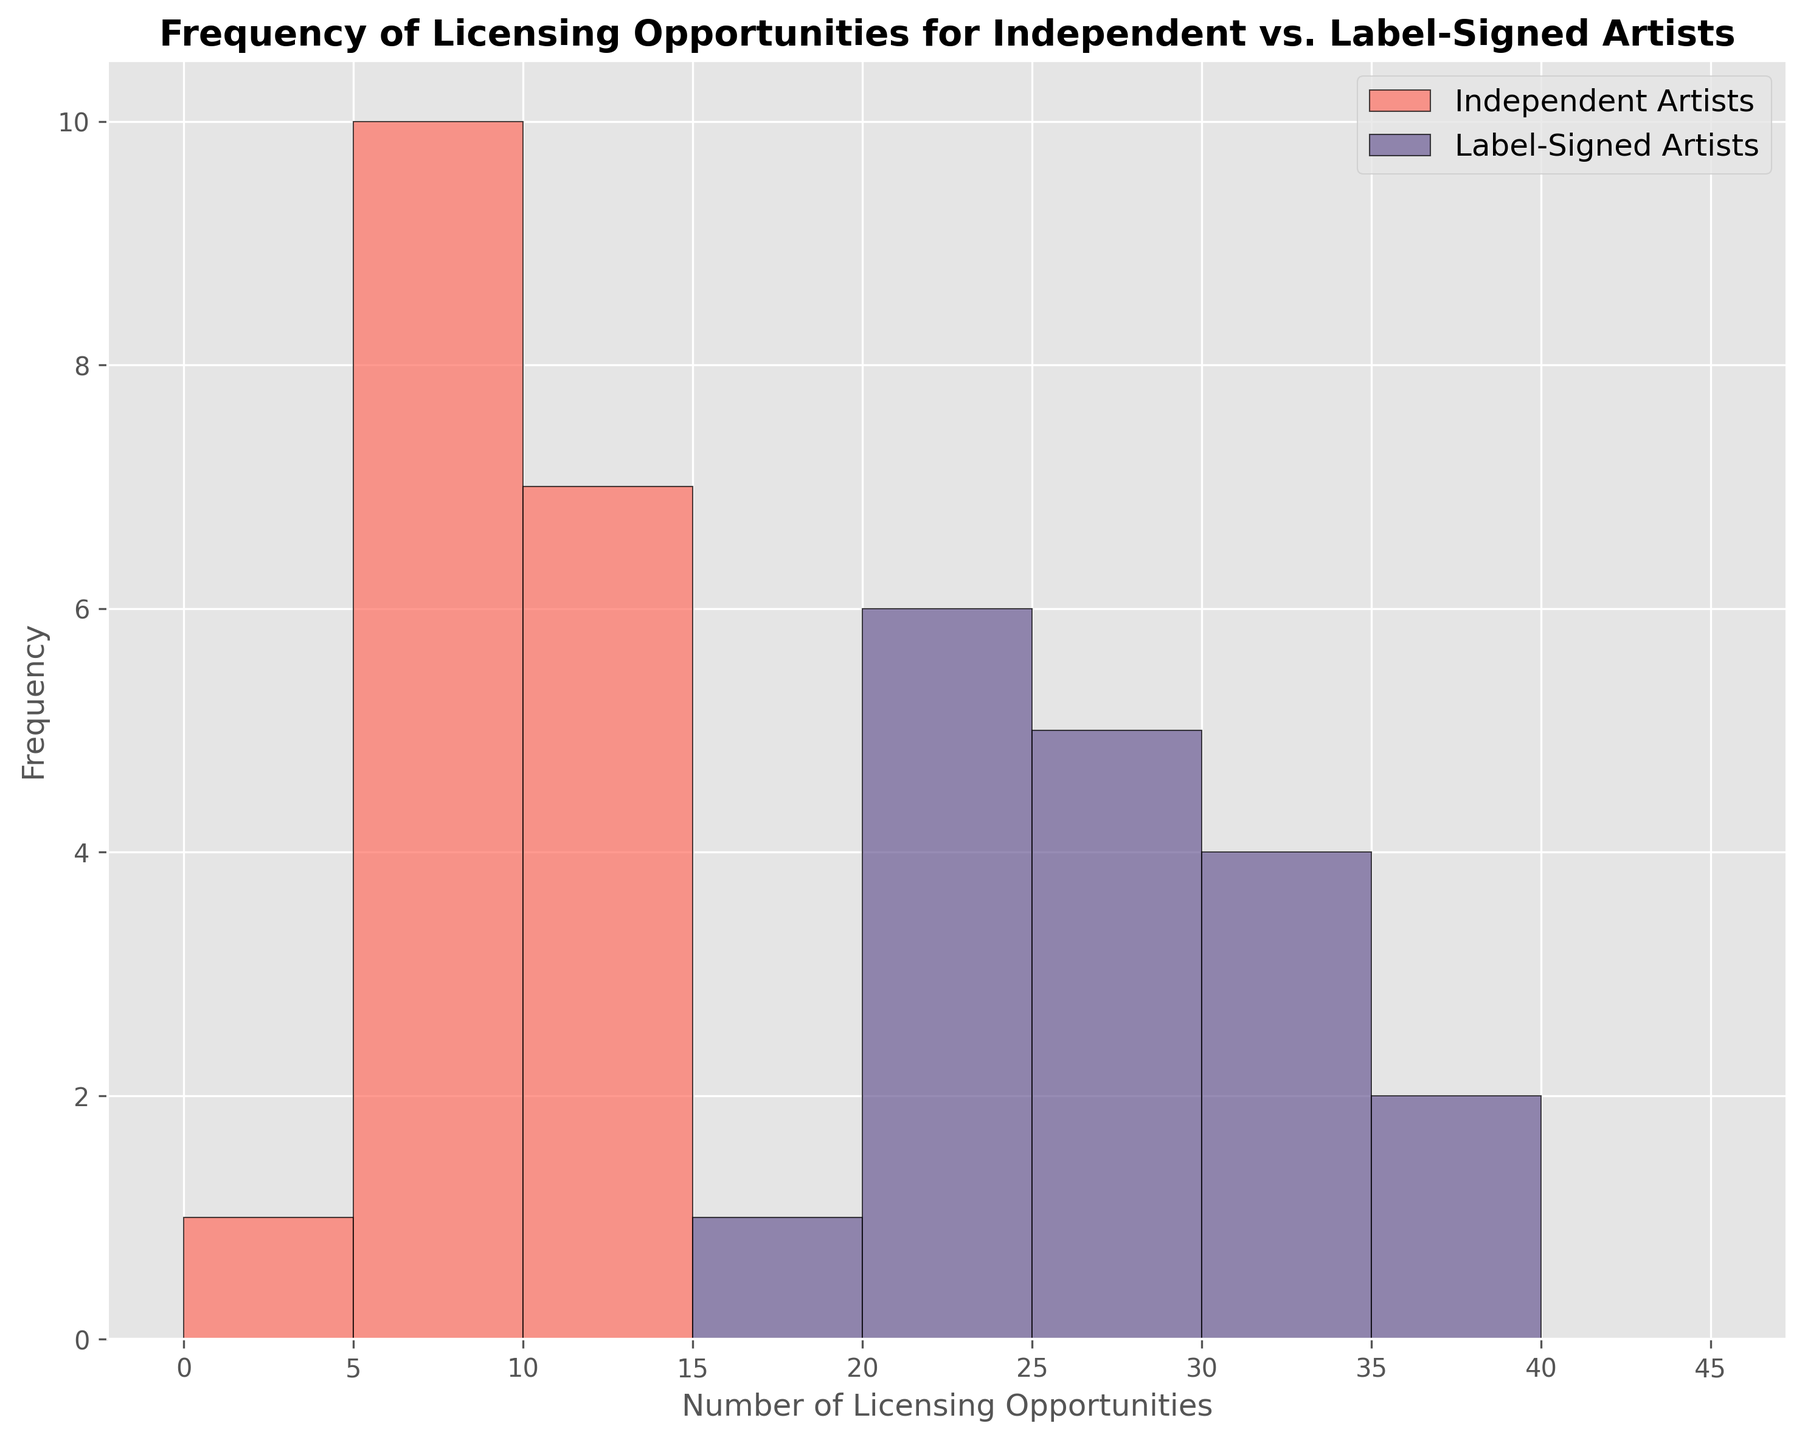What's the range of licensing opportunities for Independent Artists? The range is determined by subtracting the smallest value from the largest value. The values for Independent Artists range from 4 to 12, so the range is 12 - 4 = 8.
Answer: 8 Do Label-Signed Artists have a higher number of licensing opportunities in commercials compared to Independent Artists? To determine this, compare the heights of the bars under 'Label-Signed Artists' and 'Independent Artists' for commercials. The Label-Signed Artists have higher bars which indicate a higher count.
Answer: Yes What is the average number of licensing opportunities for Independent TV Shows? Add up the counts for Independent TV Shows (8 + 6 + 10 + 12 + 9 + 11) and divide by the number of counts (6). (8 + 6 + 10 + 12 + 9 + 11) / 6 = 56 / 6 = 9.33.
Answer: 9.33 Which category, Independent or Label-Signed, has the most frequent maximum bin count? By observing the histogram, Label-Signed Artists frequently appear in the higher bins (30-35) for all categories.
Answer: Label-Signed Are there more TV show or movie opportunities for Label-Signed Artists? Compare the cumulative bar heights for TV shows and movies for Label-Signed Artists. TV shows have taller bars more frequently.
Answer: TV shows Is there any overlap in the number of opportunities between independent and label-signed artists? Observing the histogram, bins in the range (around 20-25) have overlapping bars, indicating overlap.
Answer: Yes What is the median number of licensing opportunities for Label-Signed Commercials? List the counts (30, 35, 28, 32, 38, 33) in ascending order (28, 30, 32, 33, 35, 38). The median is the average of the middle two numbers: (32 + 33) / 2 = 32.5.
Answer: 32.5 Which group has more variability in licensing opportunities? Variability is indicated by the spread of the histogram. Independent Artists have counts spread more uniformly across bins, indicating higher variability.
Answer: Independent Artists Which category has the least variation in licensing opportunities for Label-Signed Artists? Look at the concentration of counts in bins for each category. Movies for Label-Signed Artists show less variation, as counts are more concentrated around fewer bins.
Answer: Movies 